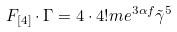Convert formula to latex. <formula><loc_0><loc_0><loc_500><loc_500>F _ { [ 4 ] } \cdot \Gamma = 4 \cdot 4 ! m e ^ { 3 \alpha f } \tilde { \gamma } ^ { 5 }</formula> 